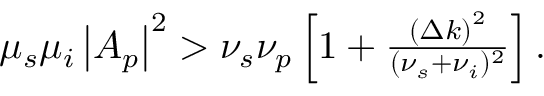<formula> <loc_0><loc_0><loc_500><loc_500>\begin{array} { r } { \mu _ { s } \mu _ { i } \left | A _ { p } \right | ^ { 2 } > \nu _ { s } \nu _ { p } \left [ 1 + \frac { \left ( \Delta k \right ) ^ { 2 } } { ( \nu _ { s } + \nu _ { i } ) ^ { 2 } } \right ] . } \end{array}</formula> 